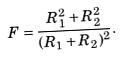<formula> <loc_0><loc_0><loc_500><loc_500>F = \frac { R _ { 1 } ^ { 2 } + R _ { 2 } ^ { 2 } } { ( R _ { 1 } + R _ { 2 } ) ^ { 2 } } .</formula> 